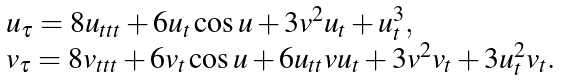Convert formula to latex. <formula><loc_0><loc_0><loc_500><loc_500>\begin{array} { l l } u _ { \tau } = 8 u _ { t t t } + 6 u _ { t } \cos u + 3 v ^ { 2 } u _ { t } + u _ { t } ^ { 3 } , \\ v _ { \tau } = 8 v _ { t t t } + 6 v _ { t } \cos u + 6 u _ { t t } v u _ { t } + 3 v ^ { 2 } v _ { t } + 3 u _ { t } ^ { 2 } v _ { t } . \end{array}</formula> 